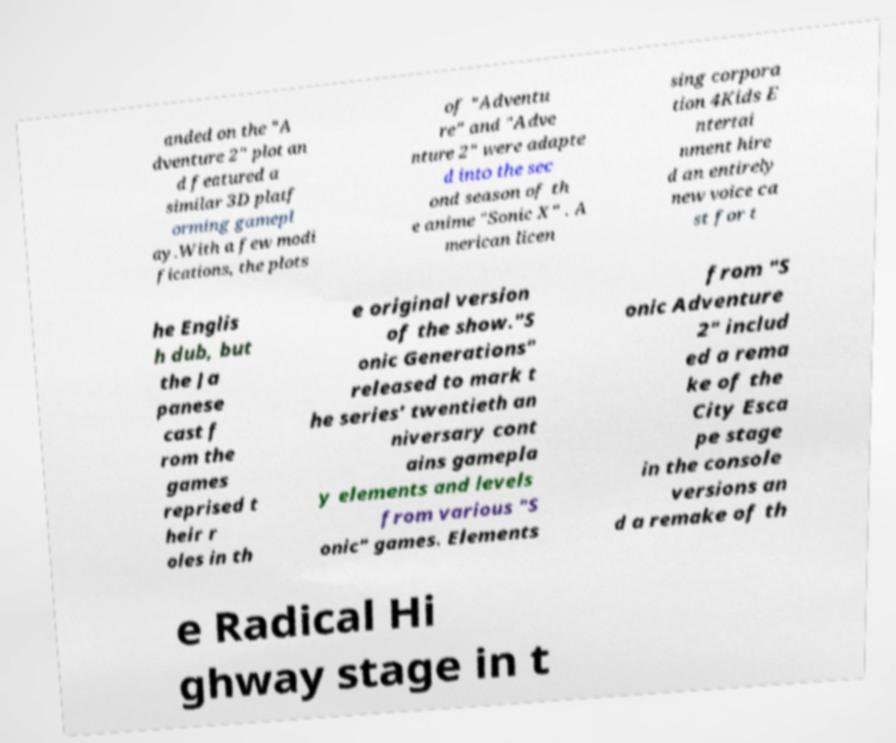Could you assist in decoding the text presented in this image and type it out clearly? anded on the "A dventure 2" plot an d featured a similar 3D platf orming gamepl ay.With a few modi fications, the plots of "Adventu re" and "Adve nture 2" were adapte d into the sec ond season of th e anime "Sonic X" . A merican licen sing corpora tion 4Kids E ntertai nment hire d an entirely new voice ca st for t he Englis h dub, but the Ja panese cast f rom the games reprised t heir r oles in th e original version of the show."S onic Generations" released to mark t he series' twentieth an niversary cont ains gamepla y elements and levels from various "S onic" games. Elements from "S onic Adventure 2" includ ed a rema ke of the City Esca pe stage in the console versions an d a remake of th e Radical Hi ghway stage in t 